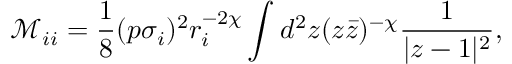Convert formula to latex. <formula><loc_0><loc_0><loc_500><loc_500>\mathcal { M } _ { i i } = \frac { 1 } { 8 } ( p \sigma _ { i } ) ^ { 2 } r _ { i } ^ { - 2 \chi } \int d ^ { 2 } z ( z \bar { z } ) ^ { - \chi } \frac { 1 } { | z - 1 | ^ { 2 } } ,</formula> 